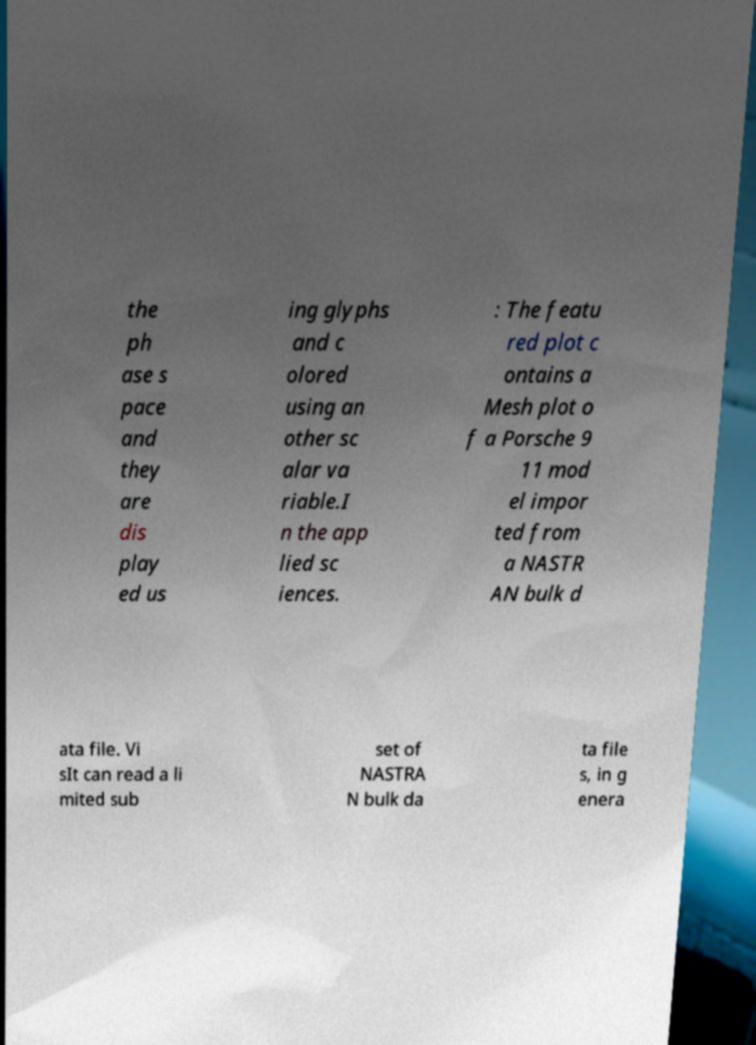There's text embedded in this image that I need extracted. Can you transcribe it verbatim? the ph ase s pace and they are dis play ed us ing glyphs and c olored using an other sc alar va riable.I n the app lied sc iences. : The featu red plot c ontains a Mesh plot o f a Porsche 9 11 mod el impor ted from a NASTR AN bulk d ata file. Vi sIt can read a li mited sub set of NASTRA N bulk da ta file s, in g enera 